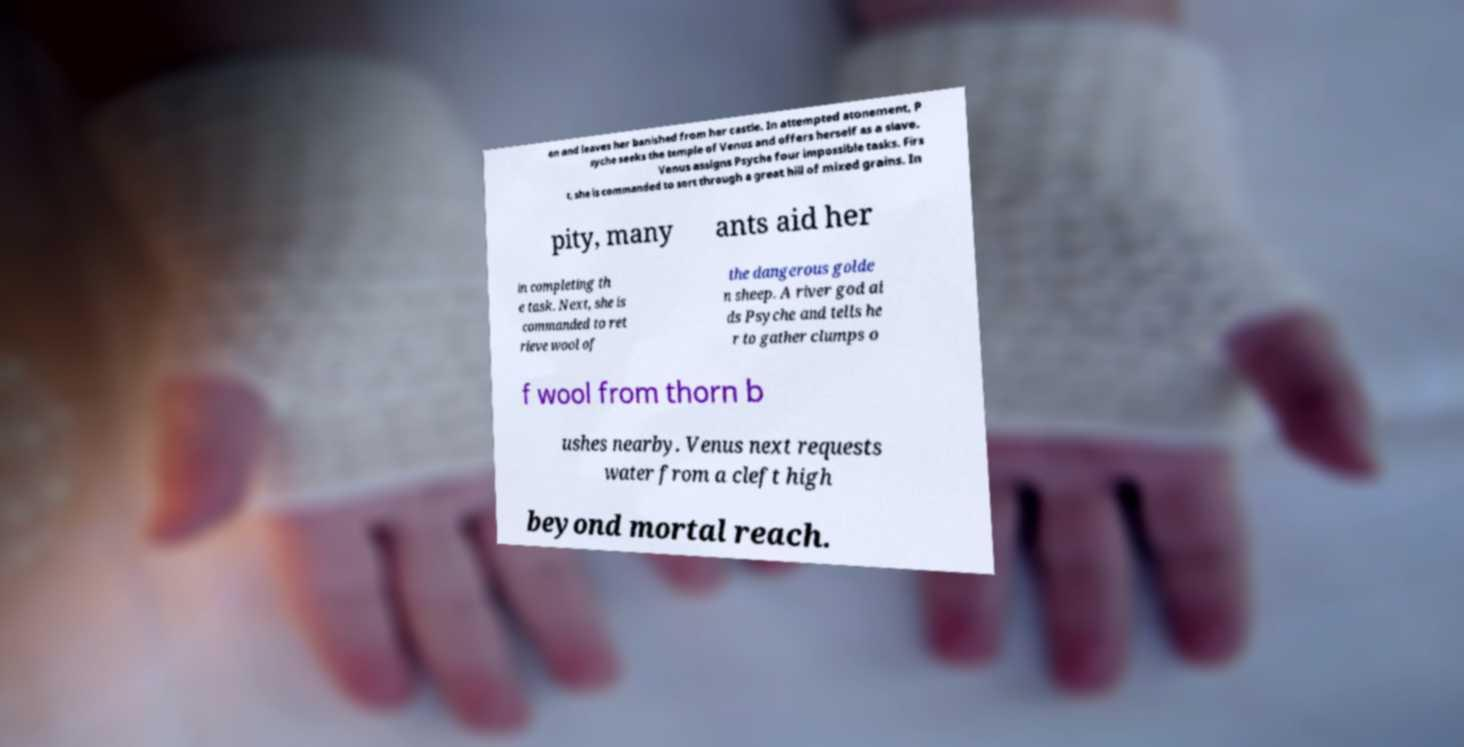What messages or text are displayed in this image? I need them in a readable, typed format. en and leaves her banished from her castle. In attempted atonement, P syche seeks the temple of Venus and offers herself as a slave. Venus assigns Psyche four impossible tasks. Firs t, she is commanded to sort through a great hill of mixed grains. In pity, many ants aid her in completing th e task. Next, she is commanded to ret rieve wool of the dangerous golde n sheep. A river god ai ds Psyche and tells he r to gather clumps o f wool from thorn b ushes nearby. Venus next requests water from a cleft high beyond mortal reach. 